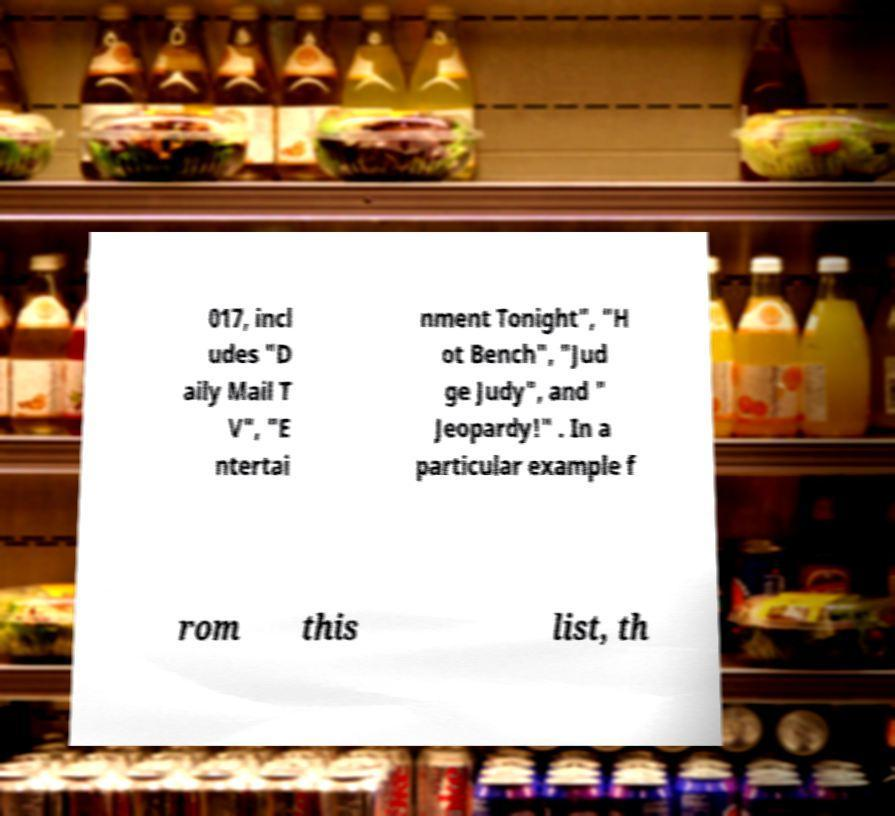Can you accurately transcribe the text from the provided image for me? 017, incl udes "D aily Mail T V", "E ntertai nment Tonight", "H ot Bench", "Jud ge Judy", and " Jeopardy!" . In a particular example f rom this list, th 